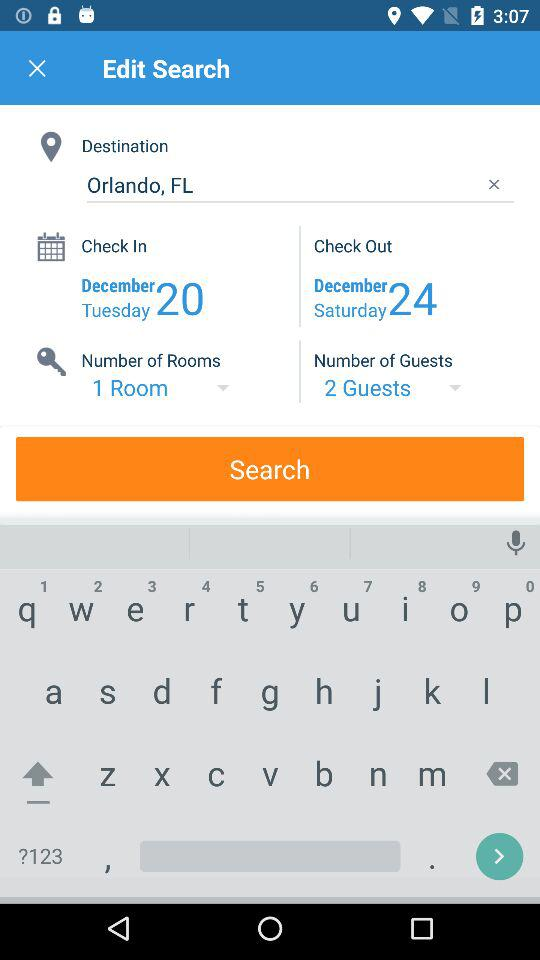What is the number of rooms? The number of rooms is 1. 